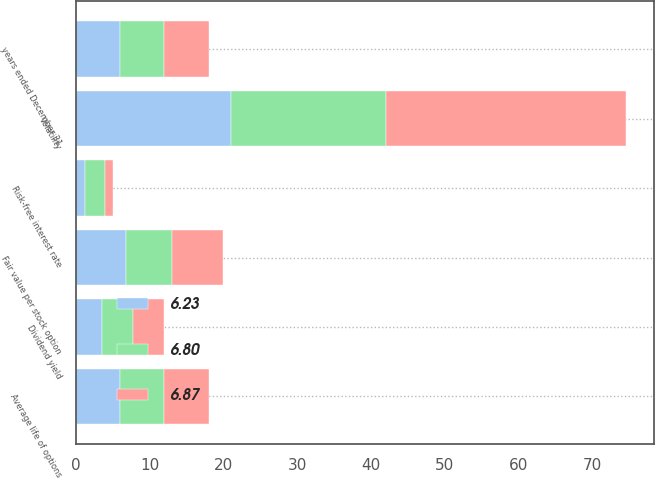<chart> <loc_0><loc_0><loc_500><loc_500><stacked_bar_chart><ecel><fcel>years ended December 31<fcel>Risk-free interest rate<fcel>Average life of options<fcel>Volatility<fcel>Dividend yield<fcel>Fair value per stock option<nl><fcel>6.87<fcel>6<fcel>1.1<fcel>6<fcel>32.63<fcel>4.3<fcel>6.87<nl><fcel>6.23<fcel>6<fcel>1.2<fcel>6<fcel>21<fcel>3.6<fcel>6.8<nl><fcel>6.8<fcel>6<fcel>2.7<fcel>6<fcel>21<fcel>4.1<fcel>6.23<nl></chart> 